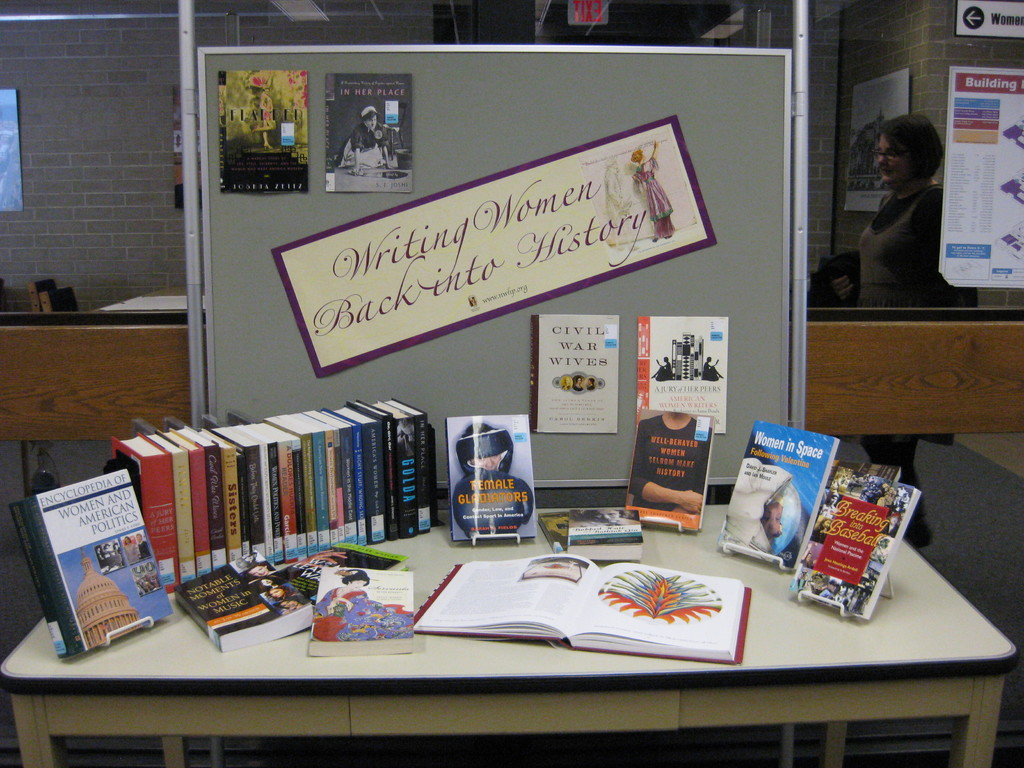What is the theme of the event showcased in this image, and why is it significant? The theme of the event is 'Writing Women Back into History,' focusing on highlighting the often overlooked contributions of women throughout history. It's significant because it educates the public on the diverse roles women have played in shaping our society, reinforcing their value beyond traditional narratives. 